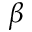<formula> <loc_0><loc_0><loc_500><loc_500>\beta</formula> 